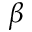<formula> <loc_0><loc_0><loc_500><loc_500>\beta</formula> 